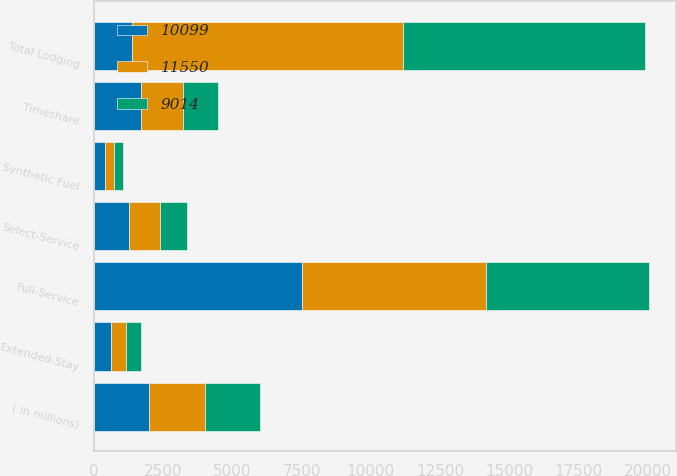Convert chart to OTSL. <chart><loc_0><loc_0><loc_500><loc_500><stacked_bar_chart><ecel><fcel>( in millions)<fcel>Full-Service<fcel>Select-Service<fcel>Extended-Stay<fcel>Timeshare<fcel>Total Lodging<fcel>Synthetic Fuel<nl><fcel>10099<fcel>2005<fcel>7535<fcel>1265<fcel>608<fcel>1721<fcel>1390.5<fcel>421<nl><fcel>11550<fcel>2004<fcel>6611<fcel>1118<fcel>547<fcel>1502<fcel>9778<fcel>321<nl><fcel>9014<fcel>2003<fcel>5876<fcel>1000<fcel>557<fcel>1279<fcel>8712<fcel>302<nl></chart> 